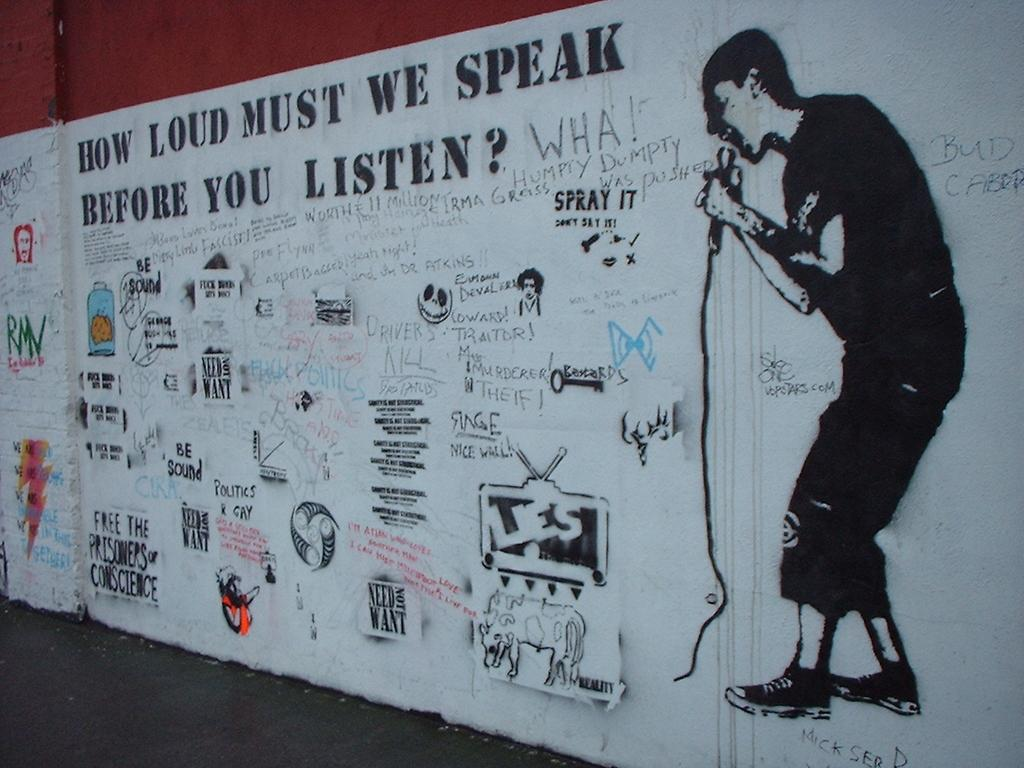What is displayed on the wall in the image? There are paintings and text on the wall in the image. Can you describe the location where the image was taken? The image may have been taken on a road. What type of juice is being exchanged between the passengers in the image? There are no passengers or juice present in the image; it only features paintings and text on a wall. 